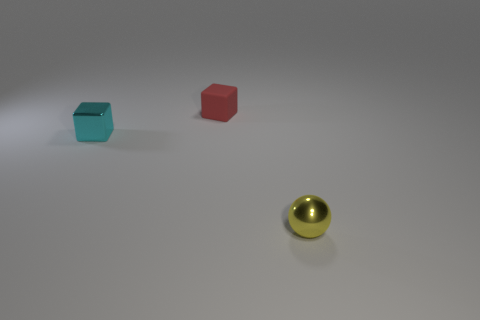Add 2 big blue metallic objects. How many objects exist? 5 Subtract all cubes. How many objects are left? 1 Subtract all small cyan cylinders. Subtract all small yellow shiny spheres. How many objects are left? 2 Add 1 tiny matte cubes. How many tiny matte cubes are left? 2 Add 3 metal blocks. How many metal blocks exist? 4 Subtract 0 blue cylinders. How many objects are left? 3 